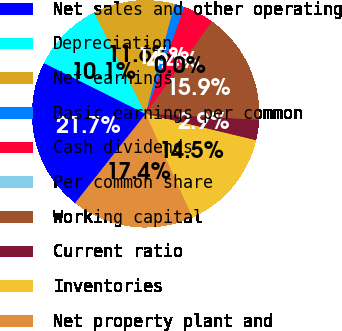<chart> <loc_0><loc_0><loc_500><loc_500><pie_chart><fcel>Net sales and other operating<fcel>Depreciation<fcel>Net earnings<fcel>Basic earnings per common<fcel>Cash dividends<fcel>Per common share<fcel>Working capital<fcel>Current ratio<fcel>Inventories<fcel>Net property plant and<nl><fcel>21.74%<fcel>10.14%<fcel>11.59%<fcel>1.45%<fcel>4.35%<fcel>0.0%<fcel>15.94%<fcel>2.9%<fcel>14.49%<fcel>17.39%<nl></chart> 